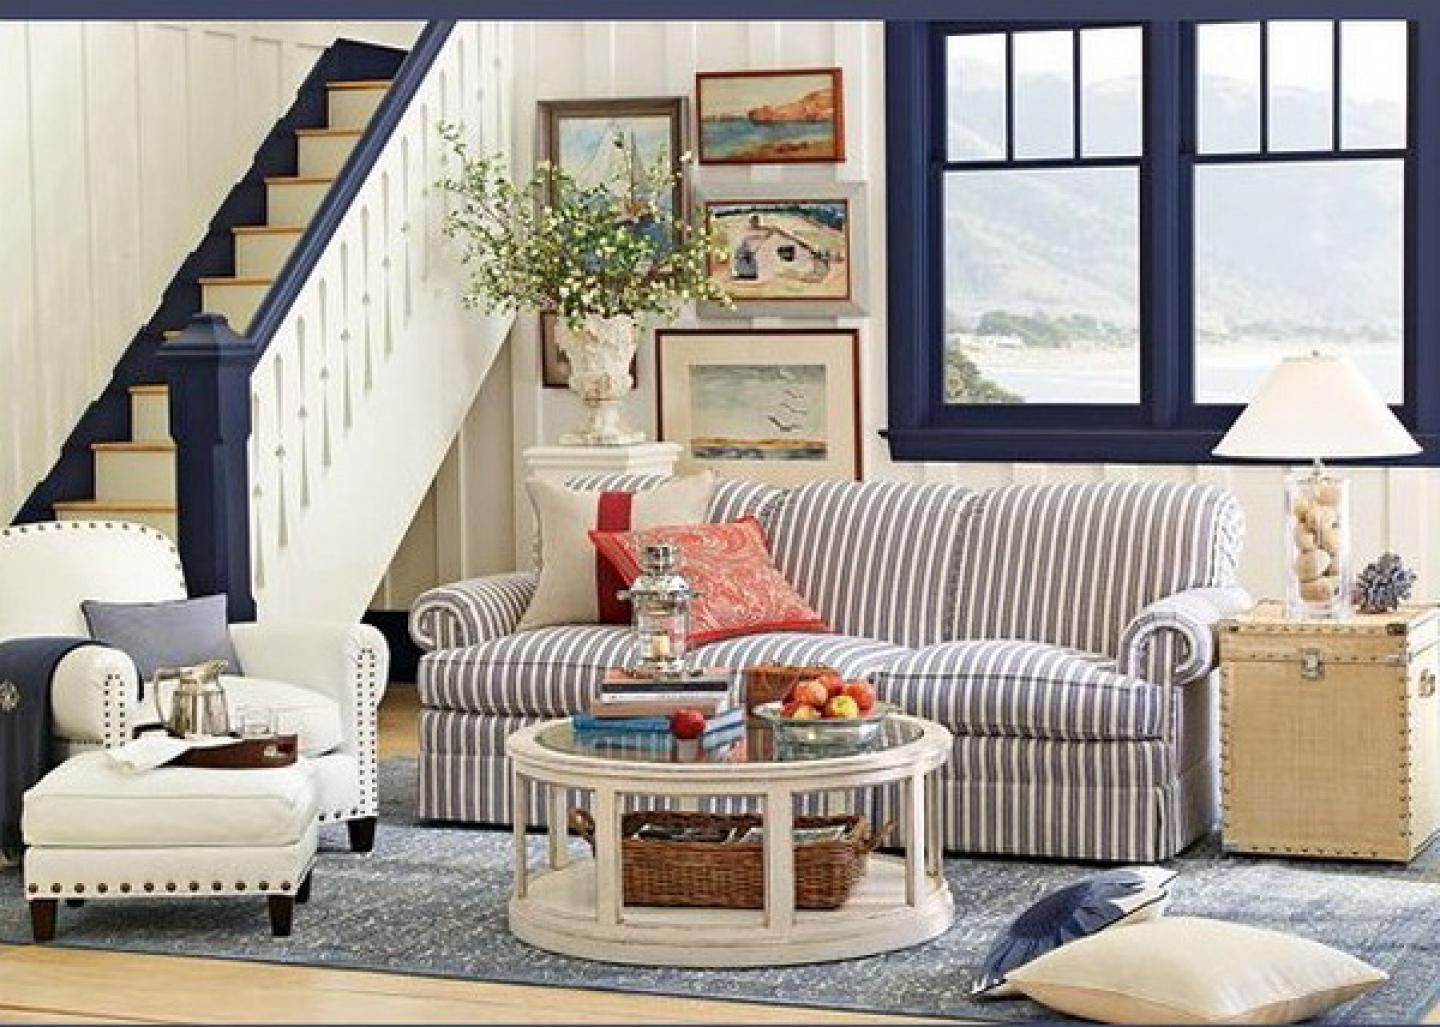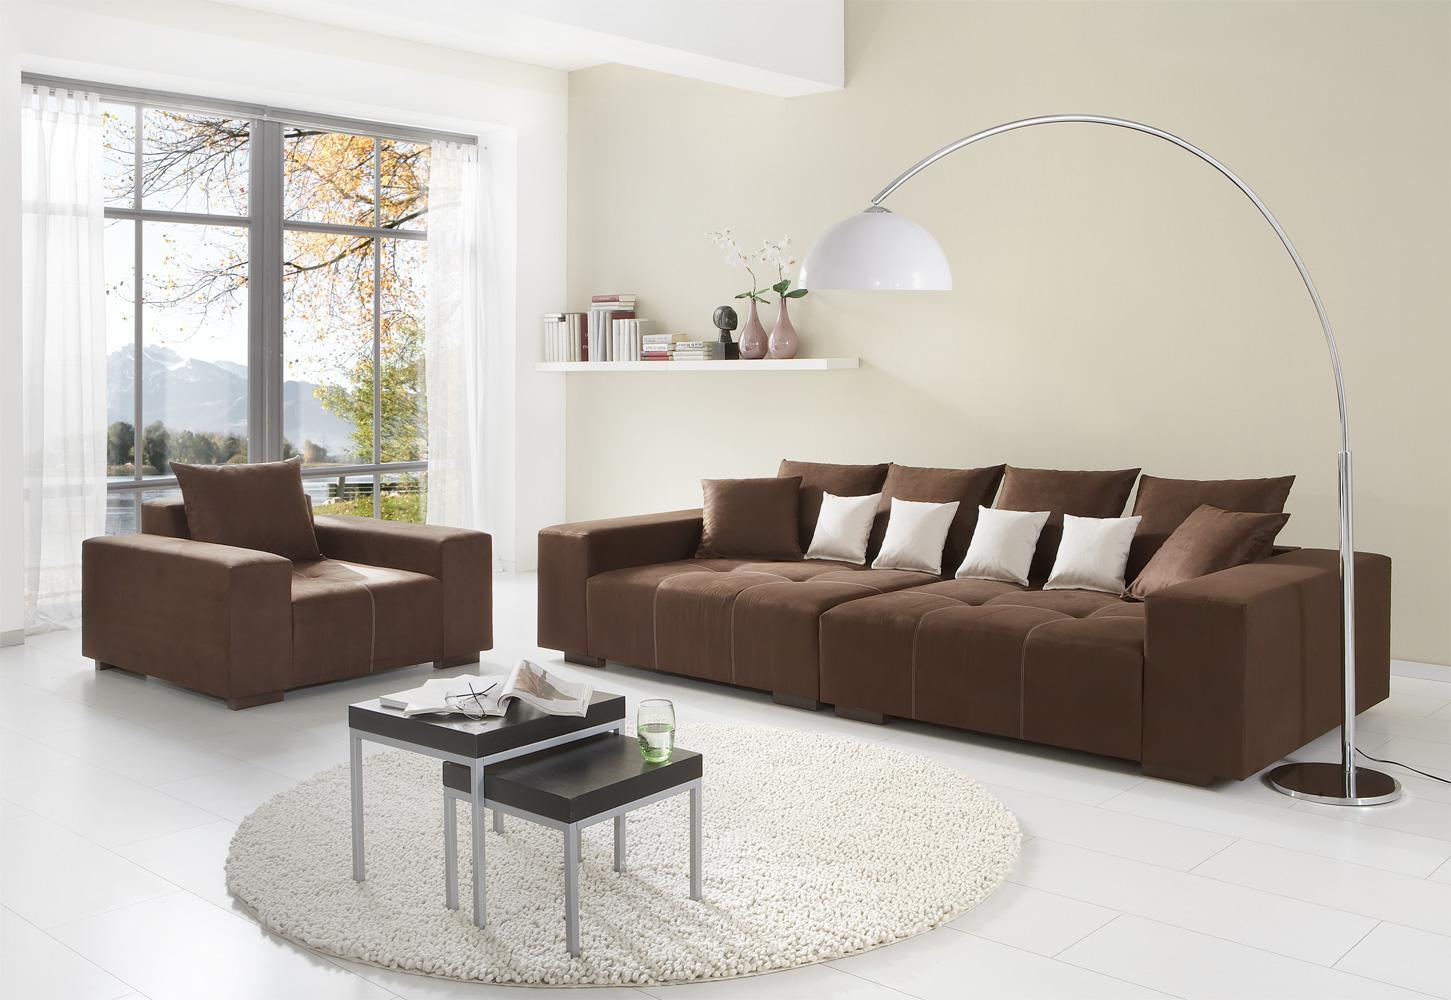The first image is the image on the left, the second image is the image on the right. For the images displayed, is the sentence "There is a single table lamp with a white shade to the right of a couch in the left image." factually correct? Answer yes or no. Yes. The first image is the image on the left, the second image is the image on the right. Given the left and right images, does the statement "The room on the left features a large printed rug, a vase filled with hot pink flowers, and an upholstered, tufted piece of furniture." hold true? Answer yes or no. No. 